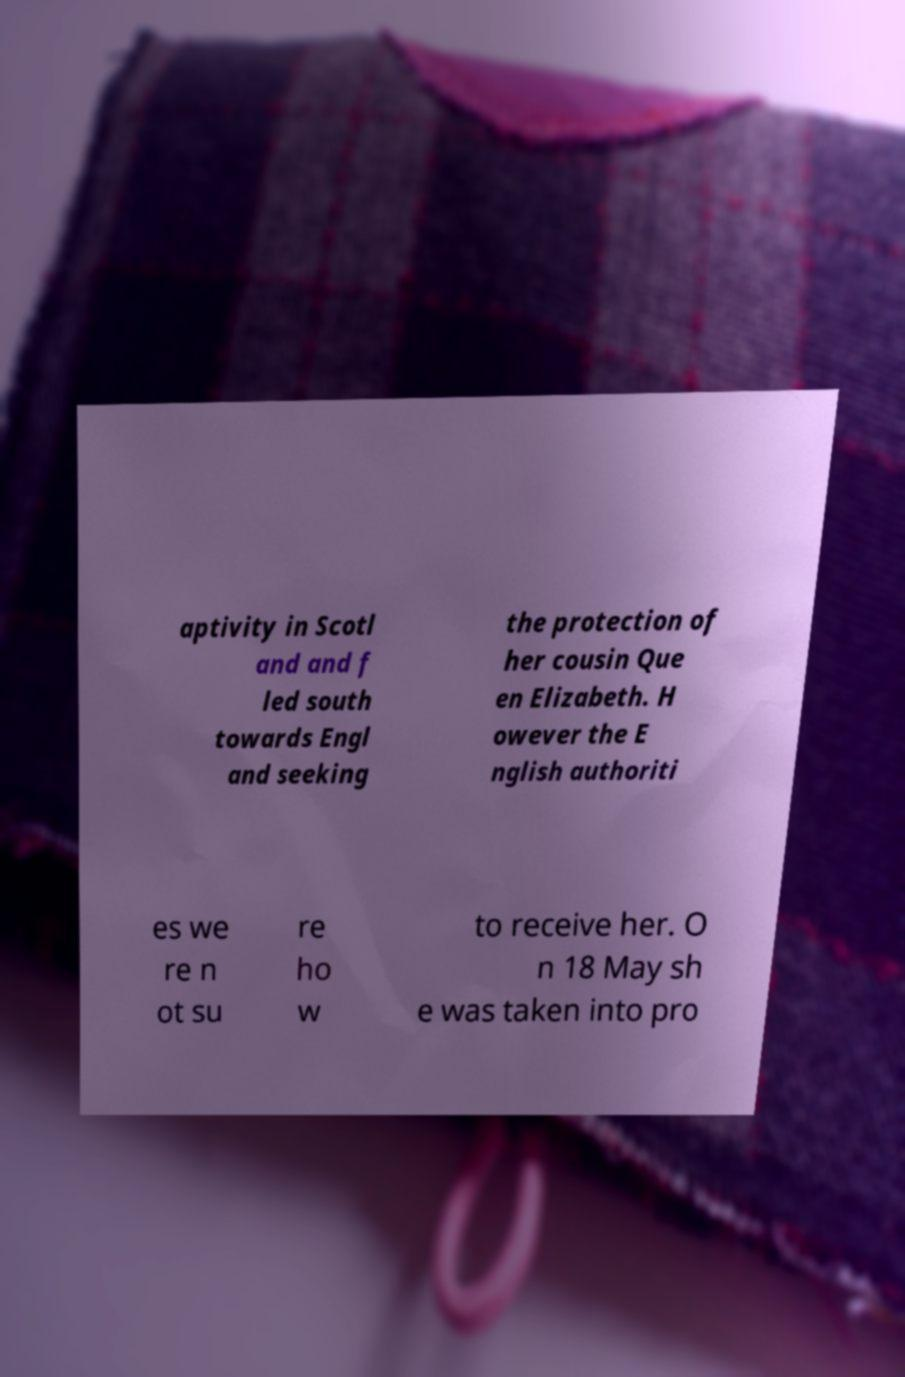I need the written content from this picture converted into text. Can you do that? aptivity in Scotl and and f led south towards Engl and seeking the protection of her cousin Que en Elizabeth. H owever the E nglish authoriti es we re n ot su re ho w to receive her. O n 18 May sh e was taken into pro 